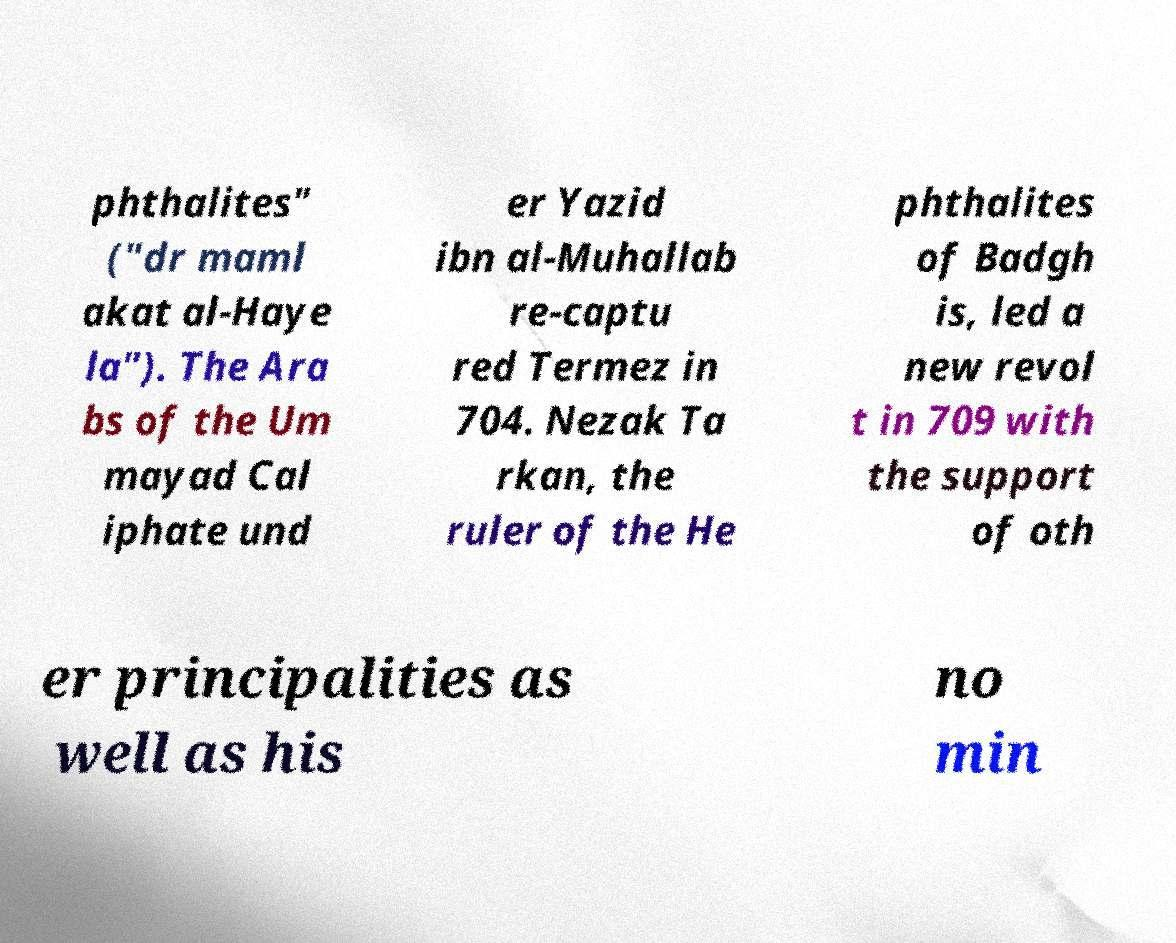What messages or text are displayed in this image? I need them in a readable, typed format. phthalites" ("dr maml akat al-Haye la"). The Ara bs of the Um mayad Cal iphate und er Yazid ibn al-Muhallab re-captu red Termez in 704. Nezak Ta rkan, the ruler of the He phthalites of Badgh is, led a new revol t in 709 with the support of oth er principalities as well as his no min 